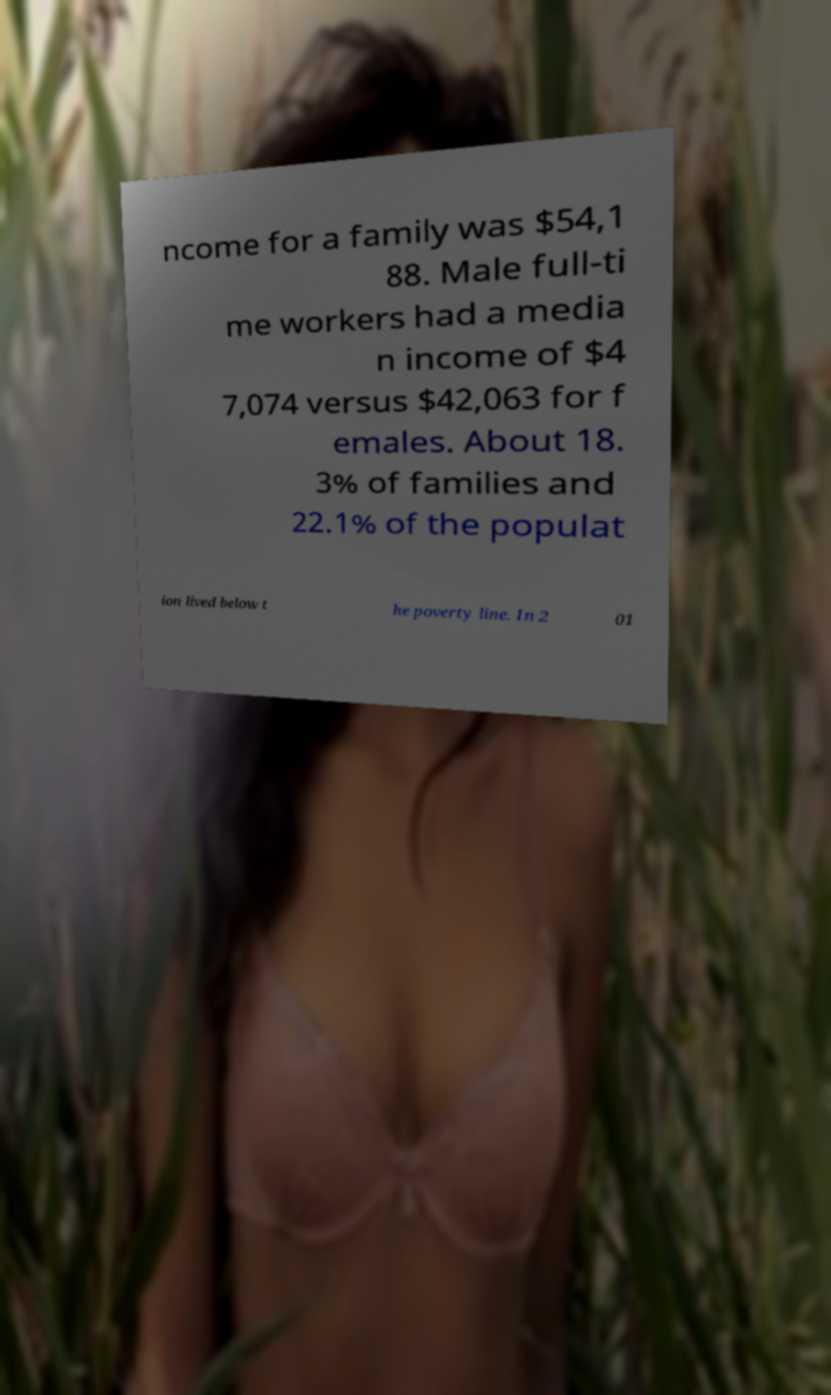What messages or text are displayed in this image? I need them in a readable, typed format. ncome for a family was $54,1 88. Male full-ti me workers had a media n income of $4 7,074 versus $42,063 for f emales. About 18. 3% of families and 22.1% of the populat ion lived below t he poverty line. In 2 01 